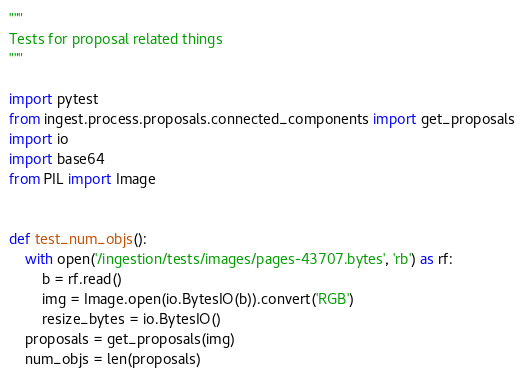Convert code to text. <code><loc_0><loc_0><loc_500><loc_500><_Python_>"""
Tests for proposal related things
"""

import pytest
from ingest.process.proposals.connected_components import get_proposals
import io
import base64
from PIL import Image


def test_num_objs():
    with open('/ingestion/tests/images/pages-43707.bytes', 'rb') as rf:
        b = rf.read()
        img = Image.open(io.BytesIO(b)).convert('RGB')
        resize_bytes = io.BytesIO()
    proposals = get_proposals(img)
    num_objs = len(proposals)</code> 